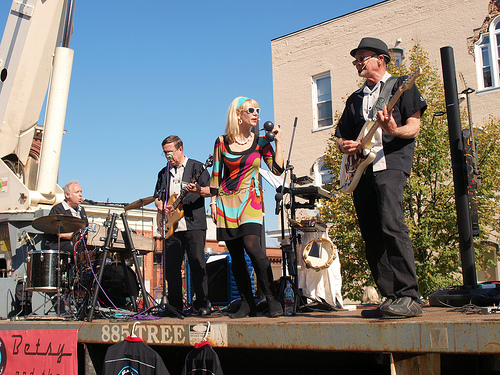<image>
Is there a woman to the right of the man? Yes. From this viewpoint, the woman is positioned to the right side relative to the man. Is there a building next to the men? No. The building is not positioned next to the men. They are located in different areas of the scene. 